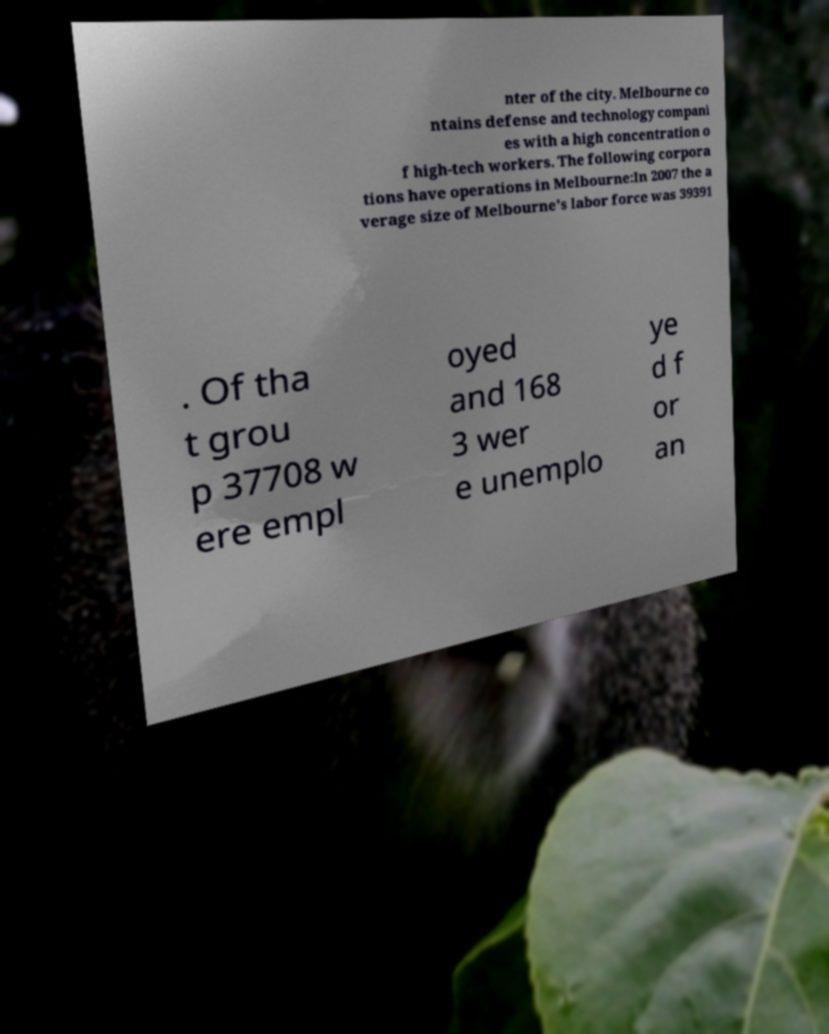What messages or text are displayed in this image? I need them in a readable, typed format. nter of the city. Melbourne co ntains defense and technology compani es with a high concentration o f high-tech workers. The following corpora tions have operations in Melbourne:In 2007 the a verage size of Melbourne's labor force was 39391 . Of tha t grou p 37708 w ere empl oyed and 168 3 wer e unemplo ye d f or an 